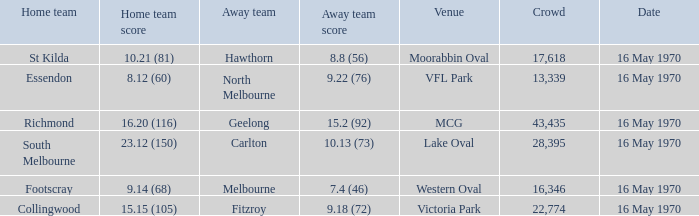What's the venue for the home team that scored 9.14 (68)? Western Oval. Can you parse all the data within this table? {'header': ['Home team', 'Home team score', 'Away team', 'Away team score', 'Venue', 'Crowd', 'Date'], 'rows': [['St Kilda', '10.21 (81)', 'Hawthorn', '8.8 (56)', 'Moorabbin Oval', '17,618', '16 May 1970'], ['Essendon', '8.12 (60)', 'North Melbourne', '9.22 (76)', 'VFL Park', '13,339', '16 May 1970'], ['Richmond', '16.20 (116)', 'Geelong', '15.2 (92)', 'MCG', '43,435', '16 May 1970'], ['South Melbourne', '23.12 (150)', 'Carlton', '10.13 (73)', 'Lake Oval', '28,395', '16 May 1970'], ['Footscray', '9.14 (68)', 'Melbourne', '7.4 (46)', 'Western Oval', '16,346', '16 May 1970'], ['Collingwood', '15.15 (105)', 'Fitzroy', '9.18 (72)', 'Victoria Park', '22,774', '16 May 1970']]} 